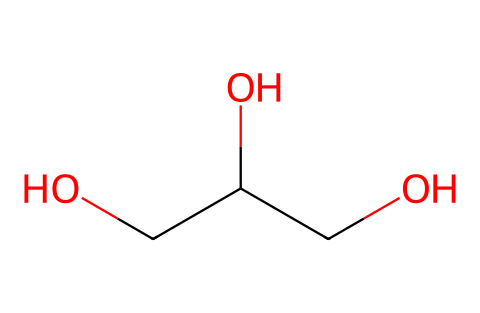What is the name of this chemical? The SMILES representation matches glycerin, which is a common moisturizing agent in cosmetics.
Answer: glycerin How many carbon atoms are in glycerin? By examining the SMILES, there are three 'C' characters, indicating three carbon atoms.
Answer: three How many hydroxyl (OH) groups are present in the molecule? The SMILES includes two 'O' characters, each part of a hydroxyl (OH) group, indicating two hydroxyl groups.
Answer: two What type of functional groups are present in glycerin? The structure shows hydroxyl groups (-OH) which are characteristic of alcohols, indicating it contains alcohol functional groups.
Answer: alcohol What is the molecular formula of glycerin? The molecule has 3 carbon (C), 8 hydrogen (H), and 3 oxygen (O) atoms; thus, its molecular formula is C3H8O3.
Answer: C3H8O3 How does the presence of hydroxyl groups affect the solubility of glycerin? The hydroxyl groups increase the polarity of glycerin, making it more soluble in water, which is common for alcoholic compounds.
Answer: increases solubility Does glycerin have a high or low viscosity compared to other liquids? Glycerin is known to be quite viscous due to its three hydroxyl groups, which contribute to strong intermolecular forces.
Answer: high viscosity 